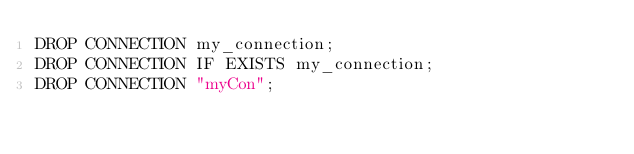<code> <loc_0><loc_0><loc_500><loc_500><_SQL_>DROP CONNECTION my_connection;
DROP CONNECTION IF EXISTS my_connection;
DROP CONNECTION "myCon";
</code> 